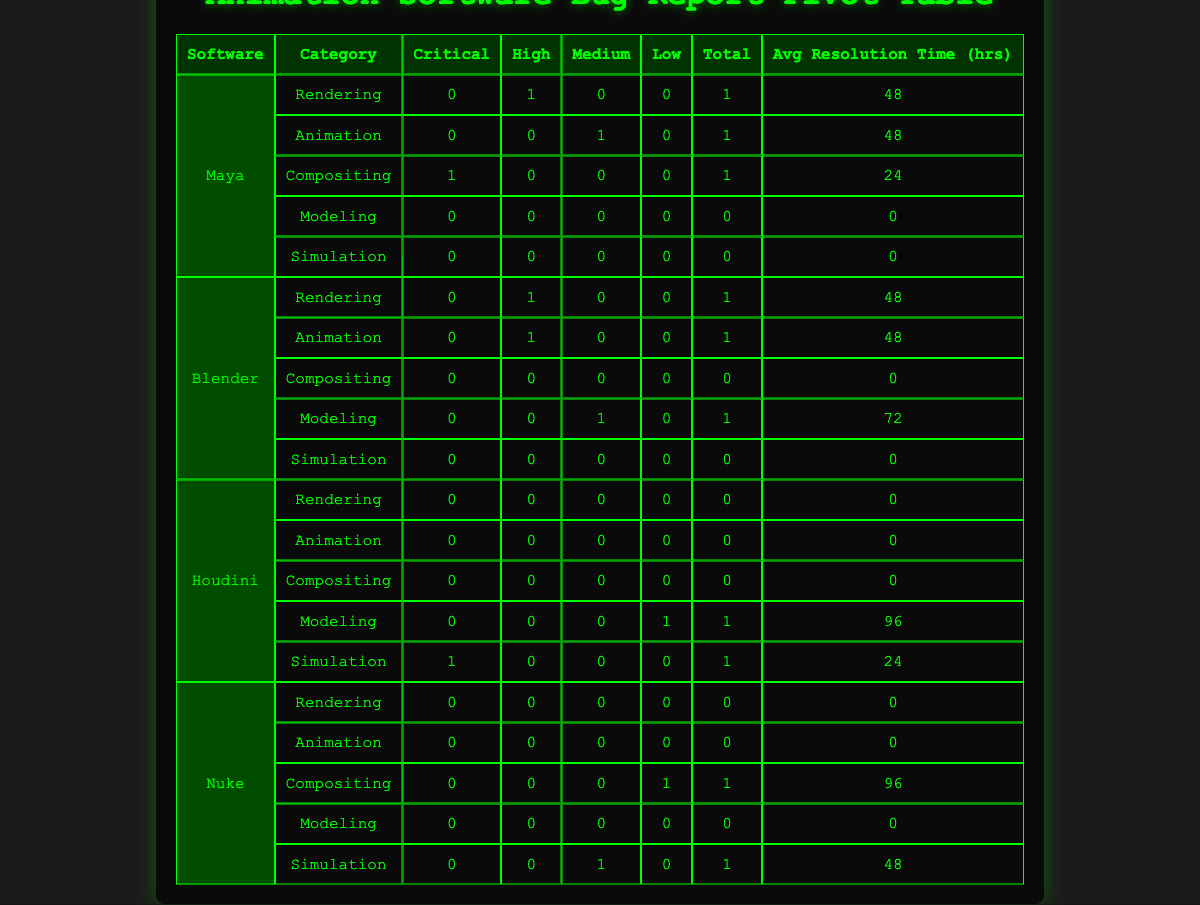What is the total number of bug reports for Maya? In the table, there are 5 rows under the software "Maya." To find the total number of bug reports, we simply count these rows.
Answer: 5 How many critical bug reports are assigned to Blender? In the row corresponding to Blender, there is only one row listing "Modeling" which has 0 critical reports. All other rows under Blender report 0 critical as well.
Answer: 0 What is the average resolution time for all bug reports categorized as Simulation? In the table, the Simulation category has bug reports for Houdini and Nuke. The resolution times are 24 hours for Houdini and 48 hours for Nuke. To calculate the average: (24 + 48) / 2 = 36.
Answer: 36 Which software has the highest average resolution time and what is that time? To find the highest average resolution time, we need to calculate the average for each software. For Maya: (48 + 48 + 24) / 3 = 40, Blender: (48 + 48 + 72) / 3 = 56, Houdini: (96 + 24) / 2 = 60, and Nuke: (96 + 48) / 2 = 72. The highest average is for Nuke at 72.
Answer: Nuke, 72 Was any bug report in the Animation category resolved in less than 48 hours? Looking at the Animation category, there are two reports: one for Maya with a resolution time of 48 hours and one for Blender with a resolution time of 48 hours as well. Since neither was resolved in under 48 hours, the answer is no.
Answer: No 